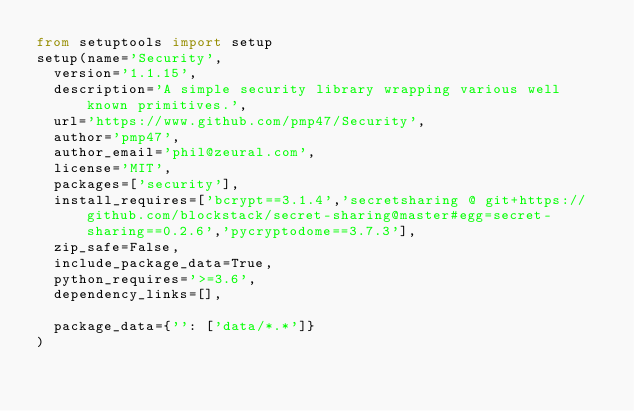<code> <loc_0><loc_0><loc_500><loc_500><_Python_>from setuptools import setup
setup(name='Security',
	version='1.1.15',
	description='A simple security library wrapping various well known primitives.',
	url='https://www.github.com/pmp47/Security',
	author='pmp47',
	author_email='phil@zeural.com',
	license='MIT',
	packages=['security'],
	install_requires=['bcrypt==3.1.4','secretsharing @ git+https://github.com/blockstack/secret-sharing@master#egg=secret-sharing==0.2.6','pycryptodome==3.7.3'],
	zip_safe=False,
	include_package_data=True,
	python_requires='>=3.6',
	dependency_links=[],

	package_data={'': ['data/*.*']}
)
</code> 